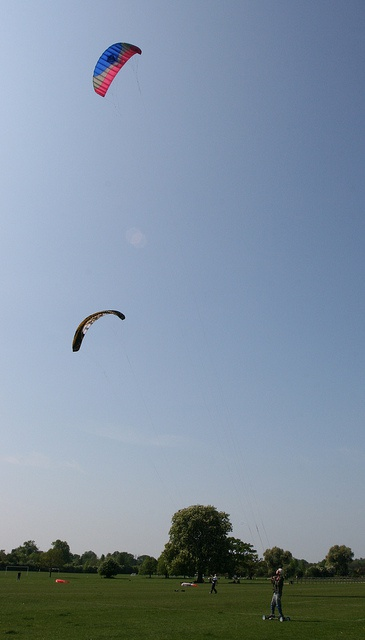Describe the objects in this image and their specific colors. I can see kite in lavender, blue, navy, brown, and salmon tones, kite in lavender, black, darkgray, and gray tones, people in lavender, black, and gray tones, people in lavender, black, gray, and darkgreen tones, and people in black, darkgreen, and lavender tones in this image. 